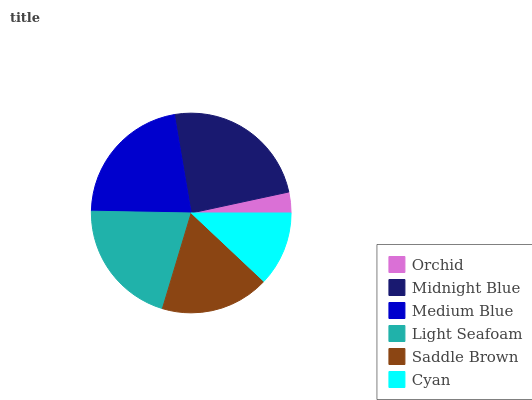Is Orchid the minimum?
Answer yes or no. Yes. Is Midnight Blue the maximum?
Answer yes or no. Yes. Is Medium Blue the minimum?
Answer yes or no. No. Is Medium Blue the maximum?
Answer yes or no. No. Is Midnight Blue greater than Medium Blue?
Answer yes or no. Yes. Is Medium Blue less than Midnight Blue?
Answer yes or no. Yes. Is Medium Blue greater than Midnight Blue?
Answer yes or no. No. Is Midnight Blue less than Medium Blue?
Answer yes or no. No. Is Light Seafoam the high median?
Answer yes or no. Yes. Is Saddle Brown the low median?
Answer yes or no. Yes. Is Orchid the high median?
Answer yes or no. No. Is Midnight Blue the low median?
Answer yes or no. No. 